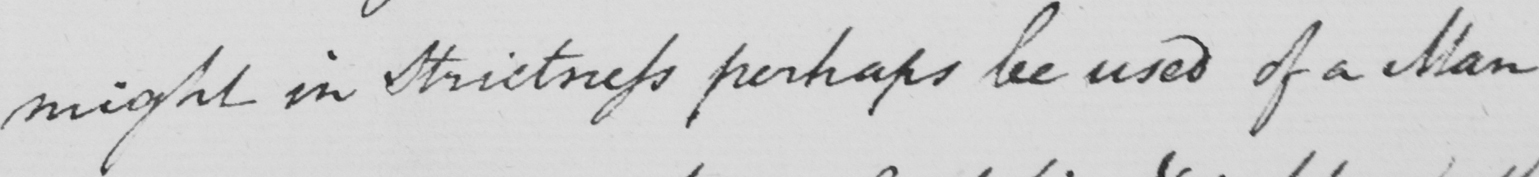Transcribe the text shown in this historical manuscript line. might in strictness perhaps be used of a Man 